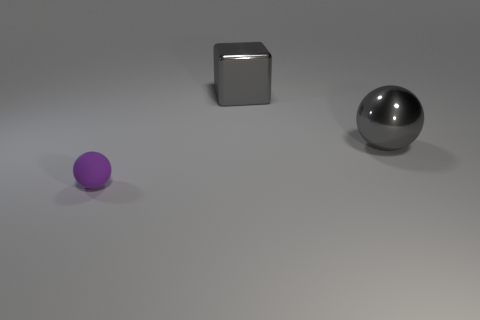There is a gray object that is the same size as the metal cube; what is its material?
Ensure brevity in your answer.  Metal. There is a thing to the right of the big gray metal object behind the sphere behind the rubber object; what is its material?
Provide a short and direct response. Metal. Does the ball that is behind the purple rubber sphere have the same size as the matte sphere?
Give a very brief answer. No. Is the number of large purple objects greater than the number of gray things?
Provide a short and direct response. No. What number of small things are either red metal cubes or purple rubber spheres?
Give a very brief answer. 1. What number of other things are there of the same color as the metallic ball?
Make the answer very short. 1. How many big objects have the same material as the block?
Make the answer very short. 1. Is the color of the ball on the left side of the gray metal ball the same as the big sphere?
Offer a terse response. No. How many cyan things are small matte spheres or shiny spheres?
Provide a succinct answer. 0. Is there anything else that is the same material as the big gray cube?
Ensure brevity in your answer.  Yes. 